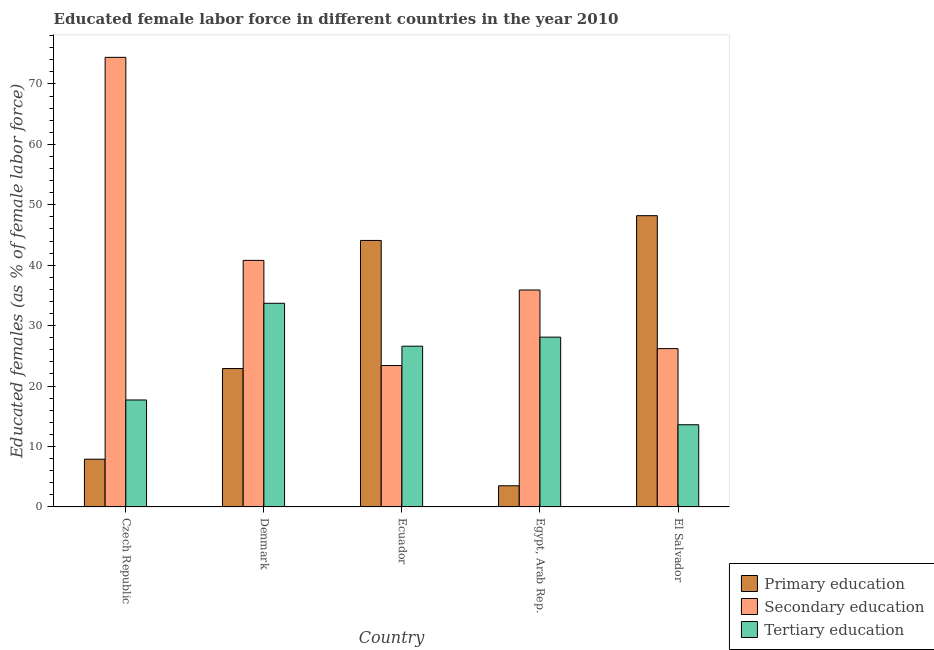How many different coloured bars are there?
Make the answer very short. 3. How many groups of bars are there?
Your answer should be compact. 5. Are the number of bars per tick equal to the number of legend labels?
Offer a terse response. Yes. Are the number of bars on each tick of the X-axis equal?
Ensure brevity in your answer.  Yes. How many bars are there on the 2nd tick from the left?
Ensure brevity in your answer.  3. How many bars are there on the 4th tick from the right?
Your answer should be very brief. 3. What is the label of the 3rd group of bars from the left?
Offer a terse response. Ecuador. What is the percentage of female labor force who received secondary education in Czech Republic?
Provide a short and direct response. 74.4. Across all countries, what is the maximum percentage of female labor force who received secondary education?
Offer a terse response. 74.4. In which country was the percentage of female labor force who received primary education maximum?
Make the answer very short. El Salvador. In which country was the percentage of female labor force who received secondary education minimum?
Provide a short and direct response. Ecuador. What is the total percentage of female labor force who received tertiary education in the graph?
Keep it short and to the point. 119.7. What is the difference between the percentage of female labor force who received tertiary education in Czech Republic and that in El Salvador?
Keep it short and to the point. 4.1. What is the difference between the percentage of female labor force who received primary education in Denmark and the percentage of female labor force who received secondary education in Egypt, Arab Rep.?
Your answer should be very brief. -13. What is the average percentage of female labor force who received tertiary education per country?
Give a very brief answer. 23.94. What is the difference between the percentage of female labor force who received primary education and percentage of female labor force who received tertiary education in Denmark?
Offer a very short reply. -10.8. What is the ratio of the percentage of female labor force who received tertiary education in Denmark to that in Ecuador?
Ensure brevity in your answer.  1.27. What is the difference between the highest and the second highest percentage of female labor force who received tertiary education?
Offer a very short reply. 5.6. What is the difference between the highest and the lowest percentage of female labor force who received primary education?
Your answer should be compact. 44.7. In how many countries, is the percentage of female labor force who received tertiary education greater than the average percentage of female labor force who received tertiary education taken over all countries?
Offer a terse response. 3. What does the 2nd bar from the left in Ecuador represents?
Keep it short and to the point. Secondary education. What does the 1st bar from the right in Ecuador represents?
Your answer should be compact. Tertiary education. Is it the case that in every country, the sum of the percentage of female labor force who received primary education and percentage of female labor force who received secondary education is greater than the percentage of female labor force who received tertiary education?
Keep it short and to the point. Yes. Are all the bars in the graph horizontal?
Make the answer very short. No. What is the difference between two consecutive major ticks on the Y-axis?
Provide a succinct answer. 10. Does the graph contain grids?
Give a very brief answer. No. How many legend labels are there?
Your answer should be compact. 3. How are the legend labels stacked?
Ensure brevity in your answer.  Vertical. What is the title of the graph?
Your answer should be compact. Educated female labor force in different countries in the year 2010. What is the label or title of the Y-axis?
Provide a succinct answer. Educated females (as % of female labor force). What is the Educated females (as % of female labor force) of Primary education in Czech Republic?
Your answer should be compact. 7.9. What is the Educated females (as % of female labor force) of Secondary education in Czech Republic?
Make the answer very short. 74.4. What is the Educated females (as % of female labor force) of Tertiary education in Czech Republic?
Offer a terse response. 17.7. What is the Educated females (as % of female labor force) of Primary education in Denmark?
Keep it short and to the point. 22.9. What is the Educated females (as % of female labor force) in Secondary education in Denmark?
Keep it short and to the point. 40.8. What is the Educated females (as % of female labor force) of Tertiary education in Denmark?
Your answer should be compact. 33.7. What is the Educated females (as % of female labor force) of Primary education in Ecuador?
Your response must be concise. 44.1. What is the Educated females (as % of female labor force) in Secondary education in Ecuador?
Your response must be concise. 23.4. What is the Educated females (as % of female labor force) of Tertiary education in Ecuador?
Give a very brief answer. 26.6. What is the Educated females (as % of female labor force) in Secondary education in Egypt, Arab Rep.?
Provide a short and direct response. 35.9. What is the Educated females (as % of female labor force) of Tertiary education in Egypt, Arab Rep.?
Your answer should be very brief. 28.1. What is the Educated females (as % of female labor force) of Primary education in El Salvador?
Offer a very short reply. 48.2. What is the Educated females (as % of female labor force) of Secondary education in El Salvador?
Provide a succinct answer. 26.2. What is the Educated females (as % of female labor force) in Tertiary education in El Salvador?
Your answer should be compact. 13.6. Across all countries, what is the maximum Educated females (as % of female labor force) of Primary education?
Provide a succinct answer. 48.2. Across all countries, what is the maximum Educated females (as % of female labor force) of Secondary education?
Offer a terse response. 74.4. Across all countries, what is the maximum Educated females (as % of female labor force) in Tertiary education?
Your answer should be compact. 33.7. Across all countries, what is the minimum Educated females (as % of female labor force) of Secondary education?
Your answer should be compact. 23.4. Across all countries, what is the minimum Educated females (as % of female labor force) of Tertiary education?
Your response must be concise. 13.6. What is the total Educated females (as % of female labor force) in Primary education in the graph?
Your answer should be compact. 126.6. What is the total Educated females (as % of female labor force) in Secondary education in the graph?
Make the answer very short. 200.7. What is the total Educated females (as % of female labor force) of Tertiary education in the graph?
Provide a succinct answer. 119.7. What is the difference between the Educated females (as % of female labor force) in Secondary education in Czech Republic and that in Denmark?
Your answer should be very brief. 33.6. What is the difference between the Educated females (as % of female labor force) of Primary education in Czech Republic and that in Ecuador?
Provide a succinct answer. -36.2. What is the difference between the Educated females (as % of female labor force) of Secondary education in Czech Republic and that in Ecuador?
Ensure brevity in your answer.  51. What is the difference between the Educated females (as % of female labor force) of Secondary education in Czech Republic and that in Egypt, Arab Rep.?
Ensure brevity in your answer.  38.5. What is the difference between the Educated females (as % of female labor force) in Tertiary education in Czech Republic and that in Egypt, Arab Rep.?
Ensure brevity in your answer.  -10.4. What is the difference between the Educated females (as % of female labor force) in Primary education in Czech Republic and that in El Salvador?
Offer a terse response. -40.3. What is the difference between the Educated females (as % of female labor force) of Secondary education in Czech Republic and that in El Salvador?
Your answer should be compact. 48.2. What is the difference between the Educated females (as % of female labor force) in Primary education in Denmark and that in Ecuador?
Your response must be concise. -21.2. What is the difference between the Educated females (as % of female labor force) in Secondary education in Denmark and that in Ecuador?
Provide a succinct answer. 17.4. What is the difference between the Educated females (as % of female labor force) in Primary education in Denmark and that in Egypt, Arab Rep.?
Provide a short and direct response. 19.4. What is the difference between the Educated females (as % of female labor force) in Secondary education in Denmark and that in Egypt, Arab Rep.?
Provide a succinct answer. 4.9. What is the difference between the Educated females (as % of female labor force) in Tertiary education in Denmark and that in Egypt, Arab Rep.?
Your answer should be very brief. 5.6. What is the difference between the Educated females (as % of female labor force) of Primary education in Denmark and that in El Salvador?
Keep it short and to the point. -25.3. What is the difference between the Educated females (as % of female labor force) of Secondary education in Denmark and that in El Salvador?
Offer a terse response. 14.6. What is the difference between the Educated females (as % of female labor force) in Tertiary education in Denmark and that in El Salvador?
Provide a succinct answer. 20.1. What is the difference between the Educated females (as % of female labor force) of Primary education in Ecuador and that in Egypt, Arab Rep.?
Provide a succinct answer. 40.6. What is the difference between the Educated females (as % of female labor force) of Primary education in Ecuador and that in El Salvador?
Provide a succinct answer. -4.1. What is the difference between the Educated females (as % of female labor force) in Secondary education in Ecuador and that in El Salvador?
Make the answer very short. -2.8. What is the difference between the Educated females (as % of female labor force) in Tertiary education in Ecuador and that in El Salvador?
Make the answer very short. 13. What is the difference between the Educated females (as % of female labor force) in Primary education in Egypt, Arab Rep. and that in El Salvador?
Your answer should be compact. -44.7. What is the difference between the Educated females (as % of female labor force) of Secondary education in Egypt, Arab Rep. and that in El Salvador?
Ensure brevity in your answer.  9.7. What is the difference between the Educated females (as % of female labor force) of Tertiary education in Egypt, Arab Rep. and that in El Salvador?
Offer a terse response. 14.5. What is the difference between the Educated females (as % of female labor force) of Primary education in Czech Republic and the Educated females (as % of female labor force) of Secondary education in Denmark?
Give a very brief answer. -32.9. What is the difference between the Educated females (as % of female labor force) in Primary education in Czech Republic and the Educated females (as % of female labor force) in Tertiary education in Denmark?
Your answer should be very brief. -25.8. What is the difference between the Educated females (as % of female labor force) of Secondary education in Czech Republic and the Educated females (as % of female labor force) of Tertiary education in Denmark?
Provide a short and direct response. 40.7. What is the difference between the Educated females (as % of female labor force) in Primary education in Czech Republic and the Educated females (as % of female labor force) in Secondary education in Ecuador?
Provide a succinct answer. -15.5. What is the difference between the Educated females (as % of female labor force) of Primary education in Czech Republic and the Educated females (as % of female labor force) of Tertiary education in Ecuador?
Keep it short and to the point. -18.7. What is the difference between the Educated females (as % of female labor force) in Secondary education in Czech Republic and the Educated females (as % of female labor force) in Tertiary education in Ecuador?
Offer a very short reply. 47.8. What is the difference between the Educated females (as % of female labor force) in Primary education in Czech Republic and the Educated females (as % of female labor force) in Secondary education in Egypt, Arab Rep.?
Offer a terse response. -28. What is the difference between the Educated females (as % of female labor force) in Primary education in Czech Republic and the Educated females (as % of female labor force) in Tertiary education in Egypt, Arab Rep.?
Offer a terse response. -20.2. What is the difference between the Educated females (as % of female labor force) of Secondary education in Czech Republic and the Educated females (as % of female labor force) of Tertiary education in Egypt, Arab Rep.?
Your answer should be compact. 46.3. What is the difference between the Educated females (as % of female labor force) in Primary education in Czech Republic and the Educated females (as % of female labor force) in Secondary education in El Salvador?
Give a very brief answer. -18.3. What is the difference between the Educated females (as % of female labor force) in Secondary education in Czech Republic and the Educated females (as % of female labor force) in Tertiary education in El Salvador?
Provide a succinct answer. 60.8. What is the difference between the Educated females (as % of female labor force) in Primary education in Denmark and the Educated females (as % of female labor force) in Tertiary education in Ecuador?
Ensure brevity in your answer.  -3.7. What is the difference between the Educated females (as % of female labor force) of Secondary education in Denmark and the Educated females (as % of female labor force) of Tertiary education in Ecuador?
Offer a terse response. 14.2. What is the difference between the Educated females (as % of female labor force) of Primary education in Denmark and the Educated females (as % of female labor force) of Secondary education in Egypt, Arab Rep.?
Offer a terse response. -13. What is the difference between the Educated females (as % of female labor force) of Primary education in Denmark and the Educated females (as % of female labor force) of Tertiary education in Egypt, Arab Rep.?
Keep it short and to the point. -5.2. What is the difference between the Educated females (as % of female labor force) of Secondary education in Denmark and the Educated females (as % of female labor force) of Tertiary education in Egypt, Arab Rep.?
Your answer should be very brief. 12.7. What is the difference between the Educated females (as % of female labor force) in Primary education in Denmark and the Educated females (as % of female labor force) in Secondary education in El Salvador?
Your response must be concise. -3.3. What is the difference between the Educated females (as % of female labor force) in Secondary education in Denmark and the Educated females (as % of female labor force) in Tertiary education in El Salvador?
Make the answer very short. 27.2. What is the difference between the Educated females (as % of female labor force) in Primary education in Ecuador and the Educated females (as % of female labor force) in Tertiary education in Egypt, Arab Rep.?
Make the answer very short. 16. What is the difference between the Educated females (as % of female labor force) in Secondary education in Ecuador and the Educated females (as % of female labor force) in Tertiary education in Egypt, Arab Rep.?
Your response must be concise. -4.7. What is the difference between the Educated females (as % of female labor force) of Primary education in Ecuador and the Educated females (as % of female labor force) of Secondary education in El Salvador?
Your answer should be compact. 17.9. What is the difference between the Educated females (as % of female labor force) in Primary education in Ecuador and the Educated females (as % of female labor force) in Tertiary education in El Salvador?
Your response must be concise. 30.5. What is the difference between the Educated females (as % of female labor force) in Primary education in Egypt, Arab Rep. and the Educated females (as % of female labor force) in Secondary education in El Salvador?
Give a very brief answer. -22.7. What is the difference between the Educated females (as % of female labor force) in Primary education in Egypt, Arab Rep. and the Educated females (as % of female labor force) in Tertiary education in El Salvador?
Offer a very short reply. -10.1. What is the difference between the Educated females (as % of female labor force) in Secondary education in Egypt, Arab Rep. and the Educated females (as % of female labor force) in Tertiary education in El Salvador?
Give a very brief answer. 22.3. What is the average Educated females (as % of female labor force) of Primary education per country?
Your answer should be compact. 25.32. What is the average Educated females (as % of female labor force) in Secondary education per country?
Offer a very short reply. 40.14. What is the average Educated females (as % of female labor force) of Tertiary education per country?
Your response must be concise. 23.94. What is the difference between the Educated females (as % of female labor force) of Primary education and Educated females (as % of female labor force) of Secondary education in Czech Republic?
Your answer should be very brief. -66.5. What is the difference between the Educated females (as % of female labor force) in Primary education and Educated females (as % of female labor force) in Tertiary education in Czech Republic?
Your response must be concise. -9.8. What is the difference between the Educated females (as % of female labor force) of Secondary education and Educated females (as % of female labor force) of Tertiary education in Czech Republic?
Your answer should be compact. 56.7. What is the difference between the Educated females (as % of female labor force) of Primary education and Educated females (as % of female labor force) of Secondary education in Denmark?
Your answer should be compact. -17.9. What is the difference between the Educated females (as % of female labor force) of Primary education and Educated females (as % of female labor force) of Tertiary education in Denmark?
Keep it short and to the point. -10.8. What is the difference between the Educated females (as % of female labor force) in Primary education and Educated females (as % of female labor force) in Secondary education in Ecuador?
Offer a very short reply. 20.7. What is the difference between the Educated females (as % of female labor force) of Secondary education and Educated females (as % of female labor force) of Tertiary education in Ecuador?
Offer a very short reply. -3.2. What is the difference between the Educated females (as % of female labor force) in Primary education and Educated females (as % of female labor force) in Secondary education in Egypt, Arab Rep.?
Your response must be concise. -32.4. What is the difference between the Educated females (as % of female labor force) in Primary education and Educated females (as % of female labor force) in Tertiary education in Egypt, Arab Rep.?
Offer a very short reply. -24.6. What is the difference between the Educated females (as % of female labor force) of Secondary education and Educated females (as % of female labor force) of Tertiary education in Egypt, Arab Rep.?
Your answer should be compact. 7.8. What is the difference between the Educated females (as % of female labor force) of Primary education and Educated females (as % of female labor force) of Tertiary education in El Salvador?
Your answer should be compact. 34.6. What is the ratio of the Educated females (as % of female labor force) of Primary education in Czech Republic to that in Denmark?
Your answer should be compact. 0.34. What is the ratio of the Educated females (as % of female labor force) in Secondary education in Czech Republic to that in Denmark?
Provide a short and direct response. 1.82. What is the ratio of the Educated females (as % of female labor force) in Tertiary education in Czech Republic to that in Denmark?
Offer a terse response. 0.53. What is the ratio of the Educated females (as % of female labor force) of Primary education in Czech Republic to that in Ecuador?
Offer a very short reply. 0.18. What is the ratio of the Educated females (as % of female labor force) in Secondary education in Czech Republic to that in Ecuador?
Give a very brief answer. 3.18. What is the ratio of the Educated females (as % of female labor force) in Tertiary education in Czech Republic to that in Ecuador?
Offer a terse response. 0.67. What is the ratio of the Educated females (as % of female labor force) of Primary education in Czech Republic to that in Egypt, Arab Rep.?
Offer a terse response. 2.26. What is the ratio of the Educated females (as % of female labor force) in Secondary education in Czech Republic to that in Egypt, Arab Rep.?
Offer a very short reply. 2.07. What is the ratio of the Educated females (as % of female labor force) in Tertiary education in Czech Republic to that in Egypt, Arab Rep.?
Provide a succinct answer. 0.63. What is the ratio of the Educated females (as % of female labor force) in Primary education in Czech Republic to that in El Salvador?
Ensure brevity in your answer.  0.16. What is the ratio of the Educated females (as % of female labor force) of Secondary education in Czech Republic to that in El Salvador?
Your answer should be very brief. 2.84. What is the ratio of the Educated females (as % of female labor force) in Tertiary education in Czech Republic to that in El Salvador?
Your answer should be very brief. 1.3. What is the ratio of the Educated females (as % of female labor force) in Primary education in Denmark to that in Ecuador?
Offer a terse response. 0.52. What is the ratio of the Educated females (as % of female labor force) in Secondary education in Denmark to that in Ecuador?
Offer a terse response. 1.74. What is the ratio of the Educated females (as % of female labor force) in Tertiary education in Denmark to that in Ecuador?
Your answer should be compact. 1.27. What is the ratio of the Educated females (as % of female labor force) in Primary education in Denmark to that in Egypt, Arab Rep.?
Give a very brief answer. 6.54. What is the ratio of the Educated females (as % of female labor force) in Secondary education in Denmark to that in Egypt, Arab Rep.?
Your answer should be very brief. 1.14. What is the ratio of the Educated females (as % of female labor force) in Tertiary education in Denmark to that in Egypt, Arab Rep.?
Give a very brief answer. 1.2. What is the ratio of the Educated females (as % of female labor force) of Primary education in Denmark to that in El Salvador?
Your answer should be very brief. 0.48. What is the ratio of the Educated females (as % of female labor force) of Secondary education in Denmark to that in El Salvador?
Offer a terse response. 1.56. What is the ratio of the Educated females (as % of female labor force) in Tertiary education in Denmark to that in El Salvador?
Keep it short and to the point. 2.48. What is the ratio of the Educated females (as % of female labor force) of Secondary education in Ecuador to that in Egypt, Arab Rep.?
Offer a terse response. 0.65. What is the ratio of the Educated females (as % of female labor force) in Tertiary education in Ecuador to that in Egypt, Arab Rep.?
Provide a short and direct response. 0.95. What is the ratio of the Educated females (as % of female labor force) in Primary education in Ecuador to that in El Salvador?
Provide a short and direct response. 0.91. What is the ratio of the Educated females (as % of female labor force) of Secondary education in Ecuador to that in El Salvador?
Your response must be concise. 0.89. What is the ratio of the Educated females (as % of female labor force) of Tertiary education in Ecuador to that in El Salvador?
Offer a very short reply. 1.96. What is the ratio of the Educated females (as % of female labor force) in Primary education in Egypt, Arab Rep. to that in El Salvador?
Offer a terse response. 0.07. What is the ratio of the Educated females (as % of female labor force) of Secondary education in Egypt, Arab Rep. to that in El Salvador?
Offer a terse response. 1.37. What is the ratio of the Educated females (as % of female labor force) of Tertiary education in Egypt, Arab Rep. to that in El Salvador?
Give a very brief answer. 2.07. What is the difference between the highest and the second highest Educated females (as % of female labor force) in Primary education?
Provide a short and direct response. 4.1. What is the difference between the highest and the second highest Educated females (as % of female labor force) in Secondary education?
Your answer should be compact. 33.6. What is the difference between the highest and the second highest Educated females (as % of female labor force) of Tertiary education?
Offer a terse response. 5.6. What is the difference between the highest and the lowest Educated females (as % of female labor force) of Primary education?
Give a very brief answer. 44.7. What is the difference between the highest and the lowest Educated females (as % of female labor force) of Secondary education?
Give a very brief answer. 51. What is the difference between the highest and the lowest Educated females (as % of female labor force) of Tertiary education?
Your answer should be very brief. 20.1. 